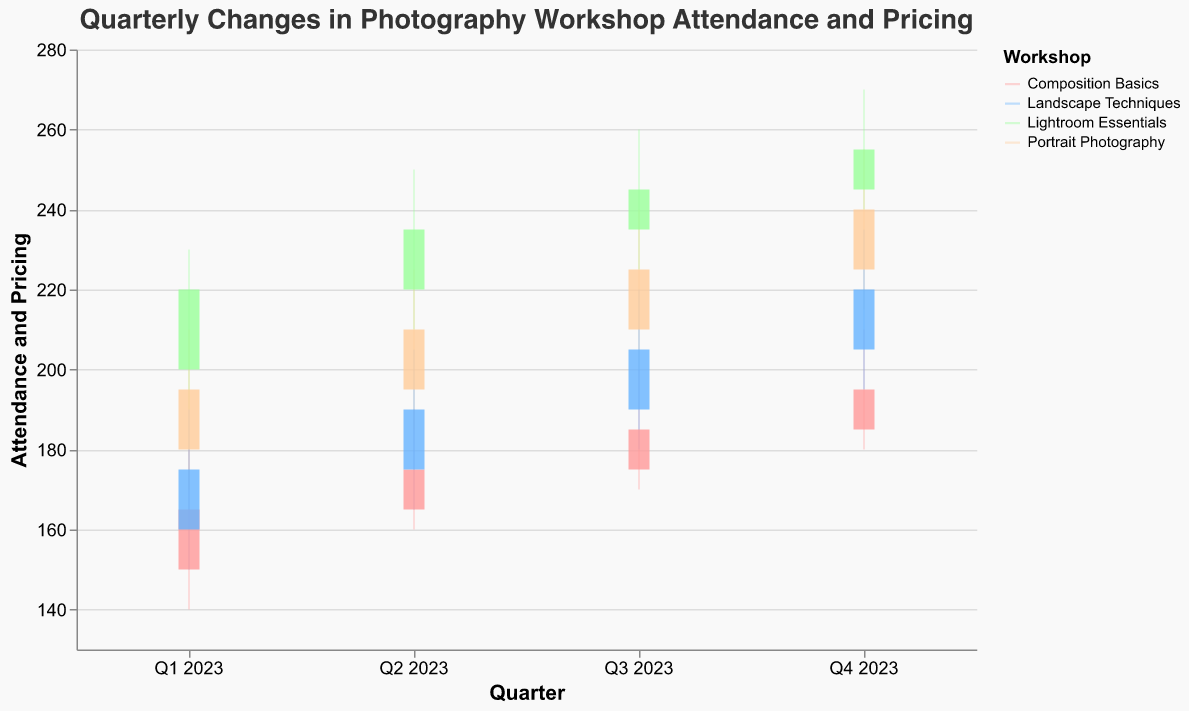What's the title of the chart? The title of the chart is displayed at the top and summarizes the content of the visual data. In this case, the title is "Quarterly Changes in Photography Workshop Attendance and Pricing".
Answer: Quarterly Changes in Photography Workshop Attendance and Pricing Which workshop had the highest closing value in Q4 2023? Look at the "Close" values for Q4 2023 for all workshops. Lightroom Essentials has the highest closing value of 255.
Answer: Lightroom Essentials What was the lowest attendance and pricing figure recorded for Composition Basics throughout 2023? Check the "Low" values for Composition Basics in each quarter. The lowest recorded value is 140 in Q1 2023.
Answer: 140 By how much did the close value for Portrait Photography increase from Q1 2023 to Q4 2023? Subtract the Close value of Q1 2023 for Portrait Photography from the Close value of Q4 2023 (240 - 195). This results in an increase of 45.
Answer: 45 Which workshop showed the most consistent increase in the closing values across each quarter? Evaluate the Close values for all workshops across the four quarters. Composition Basics shows consistent increases: 165, 175, 185, and 195.
Answer: Composition Basics How many workshops have a closing value greater than their opening value in Q3 2023? Compare the Close and Open values for each workshop in Q3 2023. All four workshops (Composition Basics, Lightroom Essentials, Portrait Photography, Landscape Techniques) have a Close value greater than their Open value.
Answer: 4 Which workshop had the widest range (High - Low) in Q2 2023? Determine the range (High - Low) for each workshop in Q2 2023. Lightroom Essentials has the widest range, with a High of 250 and a Low of 210, giving a range of 40.
Answer: Lightroom Essentials In which quarter did Landscape Techniques have the highest high value, and what was that value? Look at the "High" values for Landscape Techniques in all quarters. The highest high value is 235 in Q4 2023.
Answer: Q4 2023, 235 Which workshop exhibited the largest drop from its highest to lowest point in any single quarter? Evaluate the (High - Low) for each workshop and each quarter. Lightroom Essentials in Q1 2023 has the largest drop of 40 (230 - 190).
Answer: Lightroom Essentials in Q1 2023 